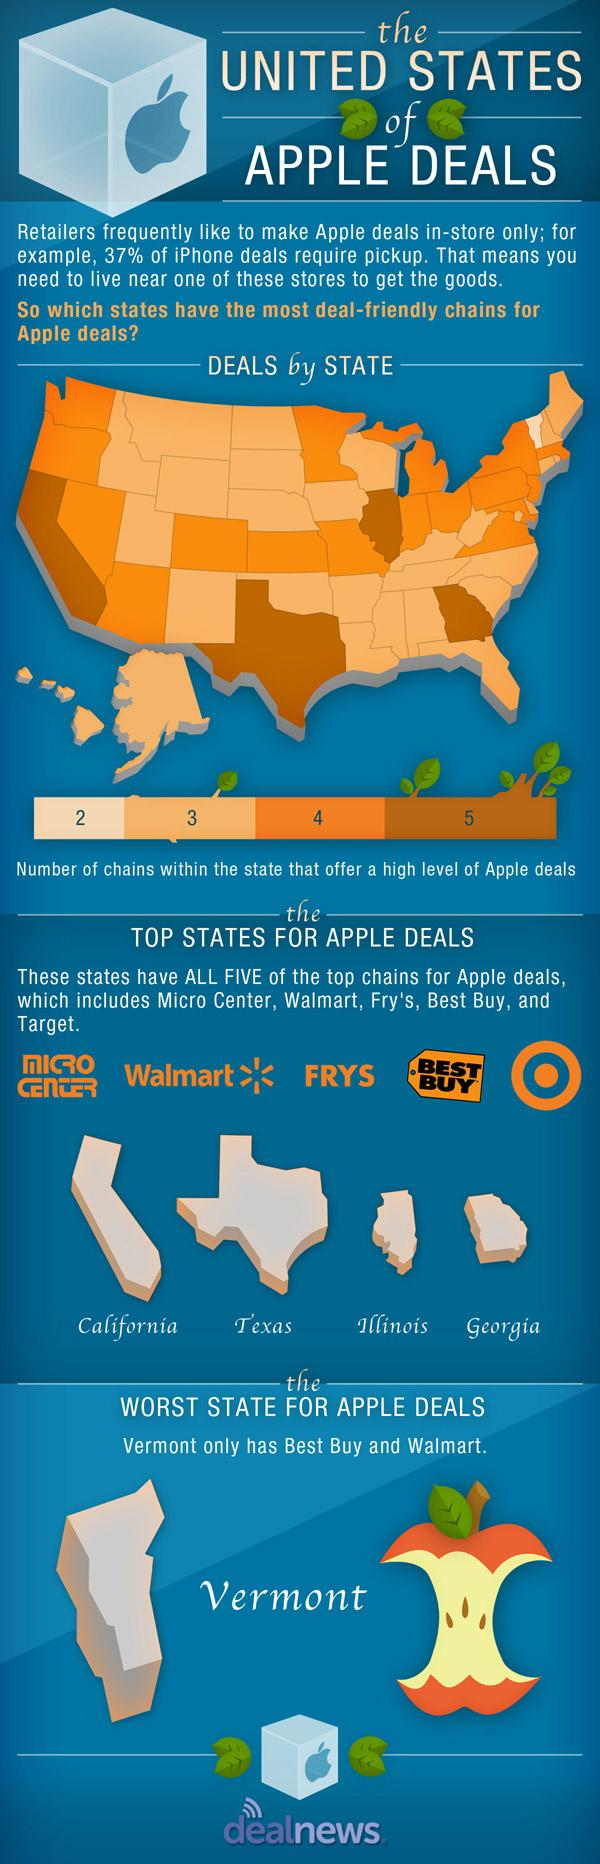Draw attention to some important aspects in this diagram. There are 4 states that have chains that offer level 5 of Apple deals. Illinois is the third highest state with the best Apple deals. 